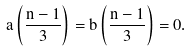Convert formula to latex. <formula><loc_0><loc_0><loc_500><loc_500>a \left ( \frac { n - 1 } { 3 } \right ) = b \left ( \frac { n - 1 } { 3 } \right ) = 0 .</formula> 